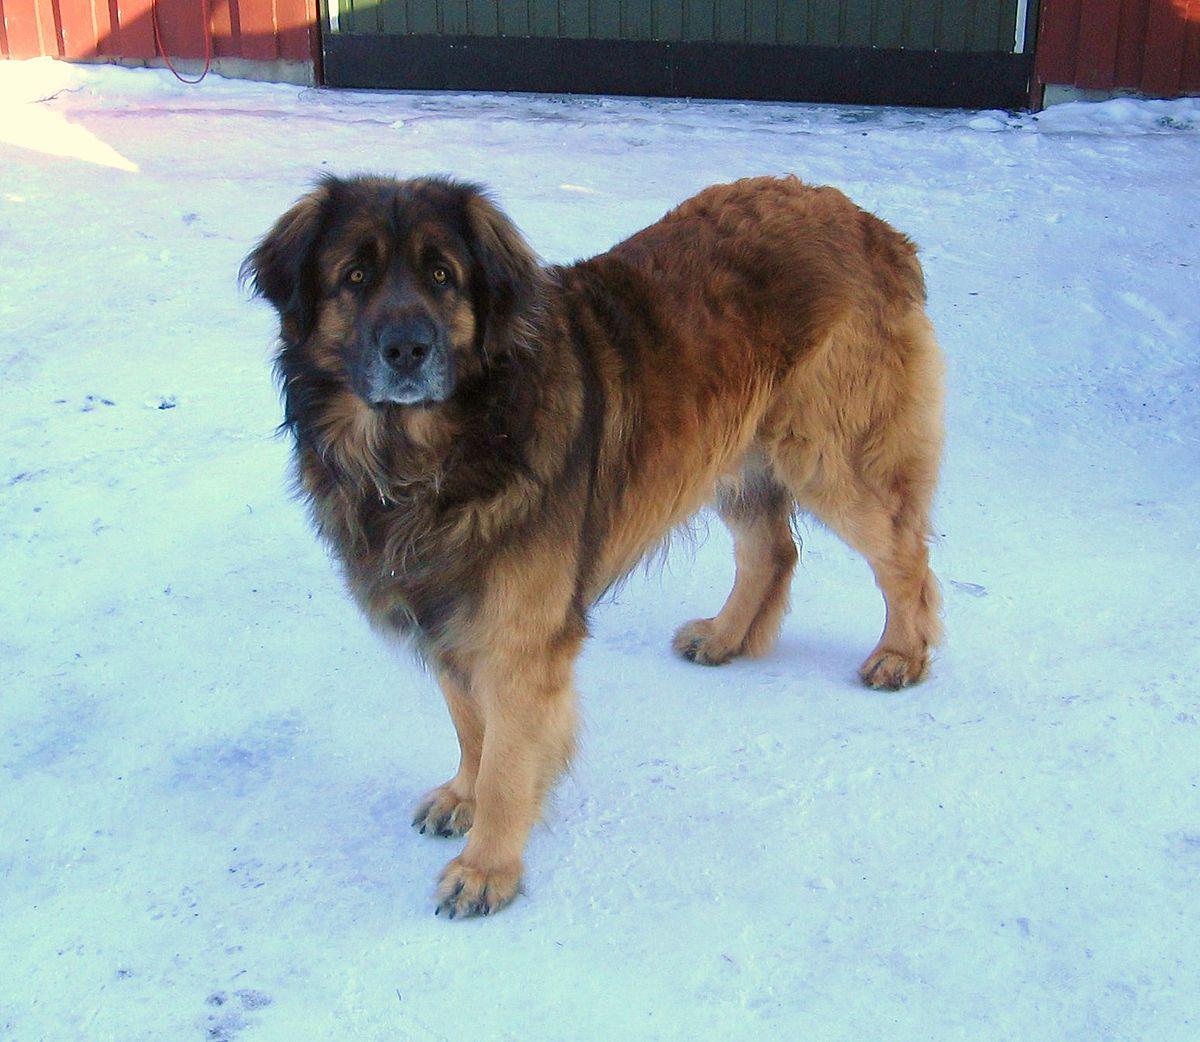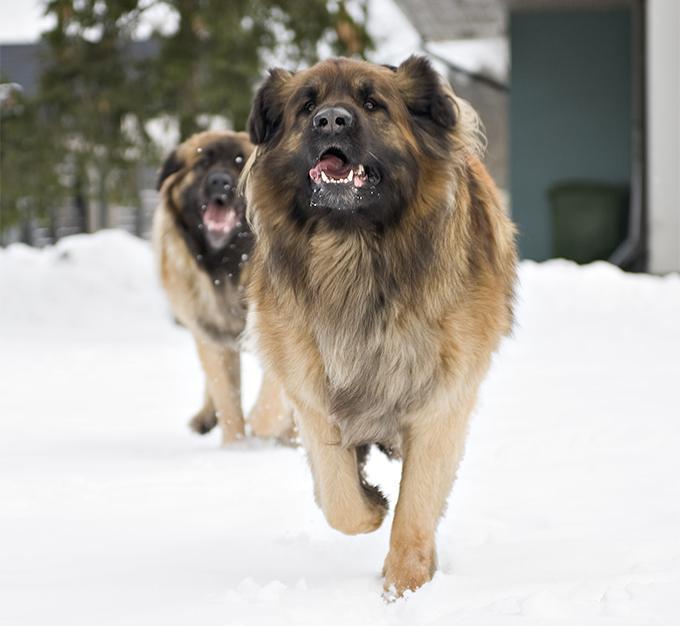The first image is the image on the left, the second image is the image on the right. Assess this claim about the two images: "No image contains a grassy ground, and at least one image contains a dog standing upright on snow.". Correct or not? Answer yes or no. Yes. The first image is the image on the left, the second image is the image on the right. Given the left and right images, does the statement "One of the images shows a single dog standing in snow." hold true? Answer yes or no. Yes. 